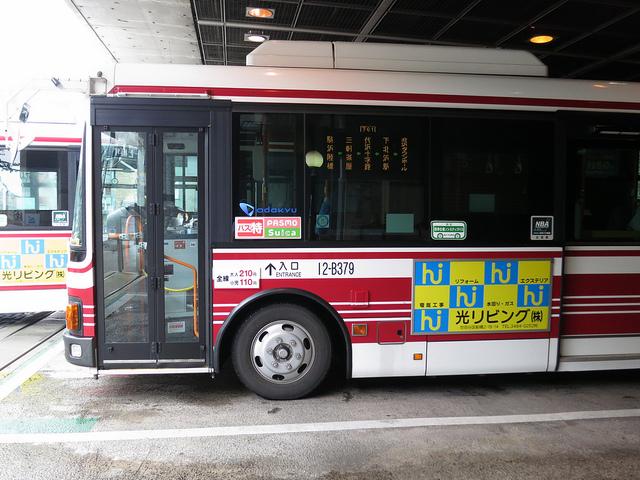What is the bus on?
Write a very short answer. Street. How many decks does the bus have?
Give a very brief answer. 1. What color are the stripes on the bus?
Concise answer only. Red. How many buses can be seen?
Give a very brief answer. 2. 